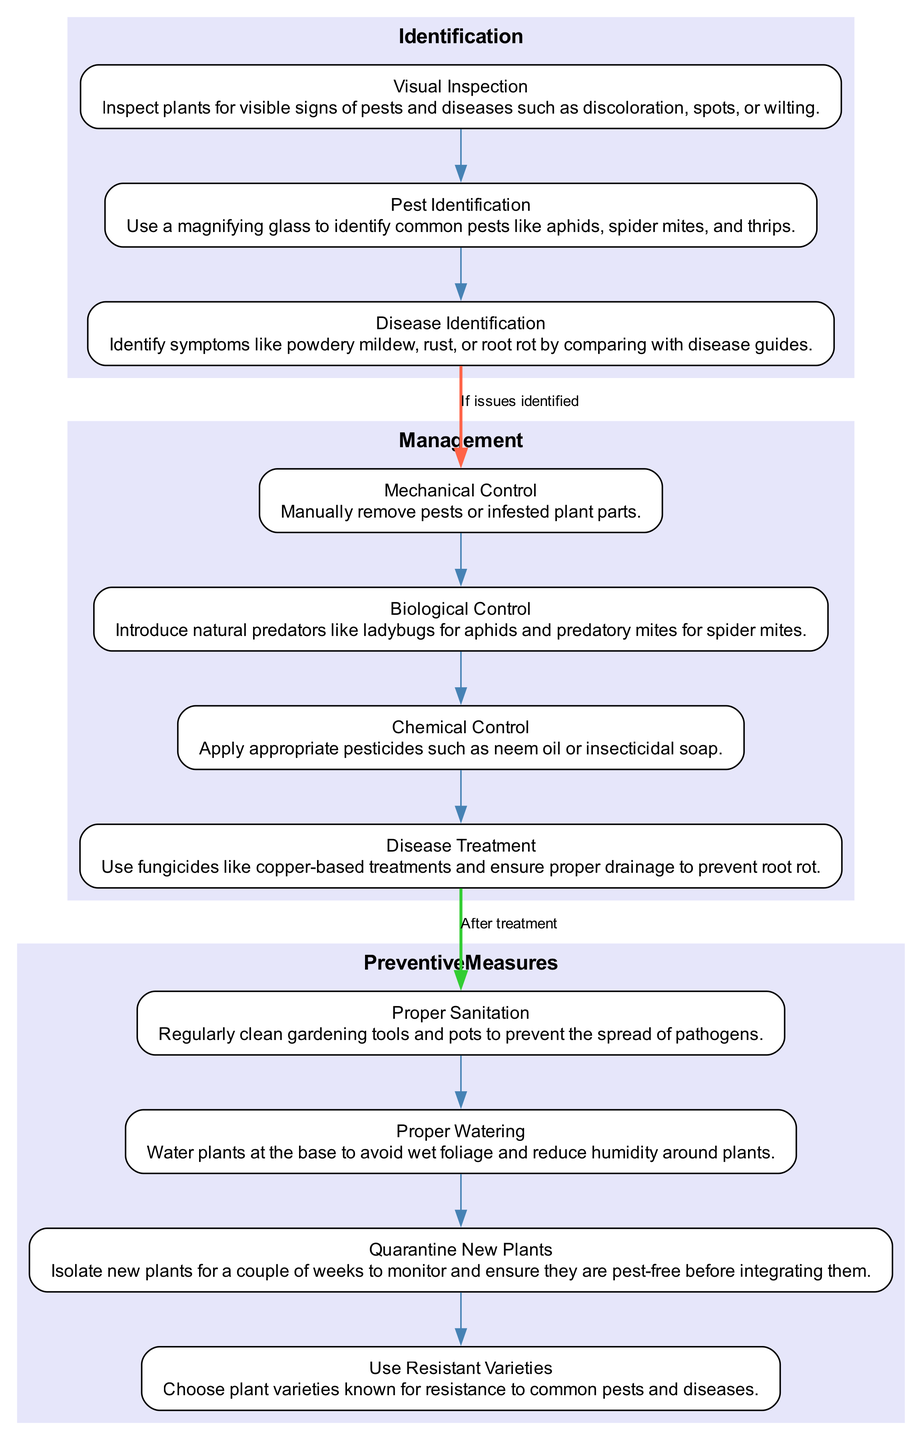What is the first step in the Identification phase? The first step listed under the Identification phase is "Visual Inspection," which focuses on inspecting plants for visible signs of pests and diseases.
Answer: Visual Inspection Which step follows "Pest Identification" in the Identification phase? After "Pest Identification," the next step is "Disease Identification," as indicated by the flow of the steps in the diagram.
Answer: Disease Identification How many steps are there in the Management phase? The Management phase contains four steps: Mechanical Control, Biological Control, Chemical Control, and Disease Treatment, making a total of four steps.
Answer: 4 What is the main action in the step titled "Proper Watering"? The action described in "Proper Watering" is to water plants at the base, which helps avoid wet foliage and reduce humidity around plants.
Answer: Water plants at the base What is the relationship between the "Identification" and "Management" phases? The relationship is that if issues are identified in the Identification phase, it leads directly to the first step in the Management phase, as shown by the connecting edge in the diagram.
Answer: If issues identified What step comes after "Disease Treatment" in the Management phase? "Disease Treatment" is the last step in the Management phase, so there is no subsequent step; this is indicated by its position in the diagram.
Answer: None What preventive measure involves isolating new plants? The preventive measure that involves isolating new plants is titled "Quarantine New Plants," which suggests isolating them for monitoring purposes before integration.
Answer: Quarantine New Plants What color represents the preventive measures section in the diagram? The preventive measures section is filled with a light purple color, which is visually represented in the diagram to separate it from other phases.
Answer: Light purple How are resistant plant varieties beneficial according to the diagram? The step "Use Resistant Varieties" indicates that choosing plant varieties known for their resistance can help in avoiding common pests and diseases, which is beneficial for plant health.
Answer: Avoiding common pests and diseases 